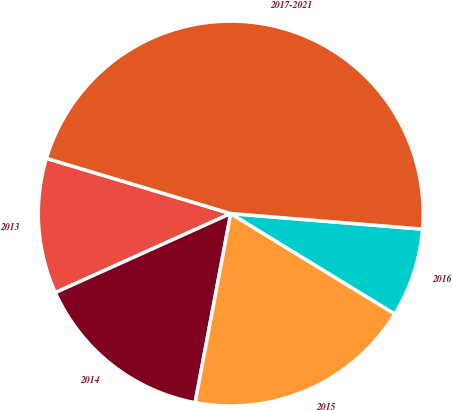Convert chart to OTSL. <chart><loc_0><loc_0><loc_500><loc_500><pie_chart><fcel>2013<fcel>2014<fcel>2015<fcel>2016<fcel>2017-2021<nl><fcel>11.37%<fcel>15.3%<fcel>19.22%<fcel>7.45%<fcel>46.66%<nl></chart> 